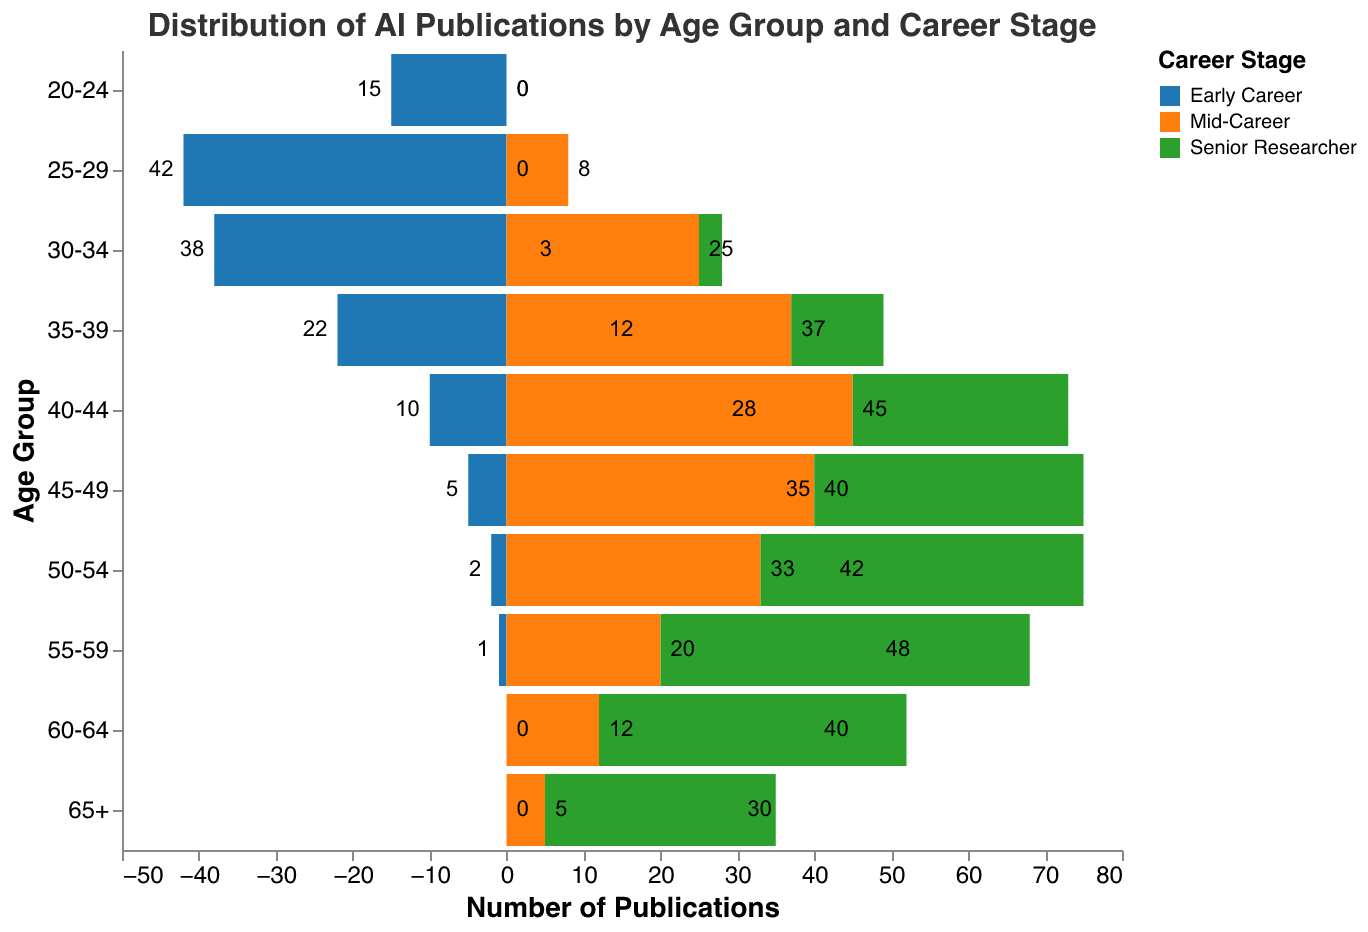What is the title of the chart? The title is displayed at the top of the figure and reads "Distribution of AI Publications by Age Group and Career Stage".
Answer: Distribution of AI Publications by Age Group and Career Stage Which age group has the highest number of early career publications? By examining the negative values on the x-axis for each age group, the highest number of early career publications is in the age group 25-29 with 42 publications.
Answer: 25-29 How many publications are contributed by senior researchers in the 55-59 age group? By looking at the bar charts on the right side (positive values) for the 55-59 age group, there are 48 publications by senior researchers.
Answer: 48 How does the number of publications by mid-career researchers in the 40-44 age group compare to those in the 45-49 age group? The bar for the 40-44 age group in the middle section is taller than the one for 45-49, indicating more publications. Specifically, the 40-44 group has 45 publications and the 45-49 group has 40 publications.
Answer: More in 40-44 Which career stage predominantly contributes to publications in the 65+ age group? By observing the height of the bars for the 65+ age group, the publications by senior researchers are the tallest, indicating that senior researchers predominantly contribute.
Answer: Senior Researchers What is the total number of publications across all age groups for mid-career researchers? Add the number of publications by mid-career researchers across all age groups: 0 + 8 + 25 + 37 + 45 + 40 + 33 + 20 + 12 + 5. The total is 225.
Answer: 225 Compare the number of early career publications in the age groups 30-34 and 35-39. Are they higher or lower? By comparing the lengths of the bars for early career publications in the two age groups, 30-34 has 38 publications while 35-39 has 22, indicating 30-34 is higher.
Answer: Higher in 30-34 Which age group shows the most balanced distribution of publications across all career stages? By comparing the bar lengths, the age group 40-44 shows a more balanced bar height across the early career, mid-career, and senior researchers.
Answer: 40-44 What is the total number of publications for the age group 50-54? Add the numbers of publications for early career (2), mid-career (33), and senior researchers (42) in the 50-54 age group: 2 + 33 + 42 = 77.
Answer: 77 